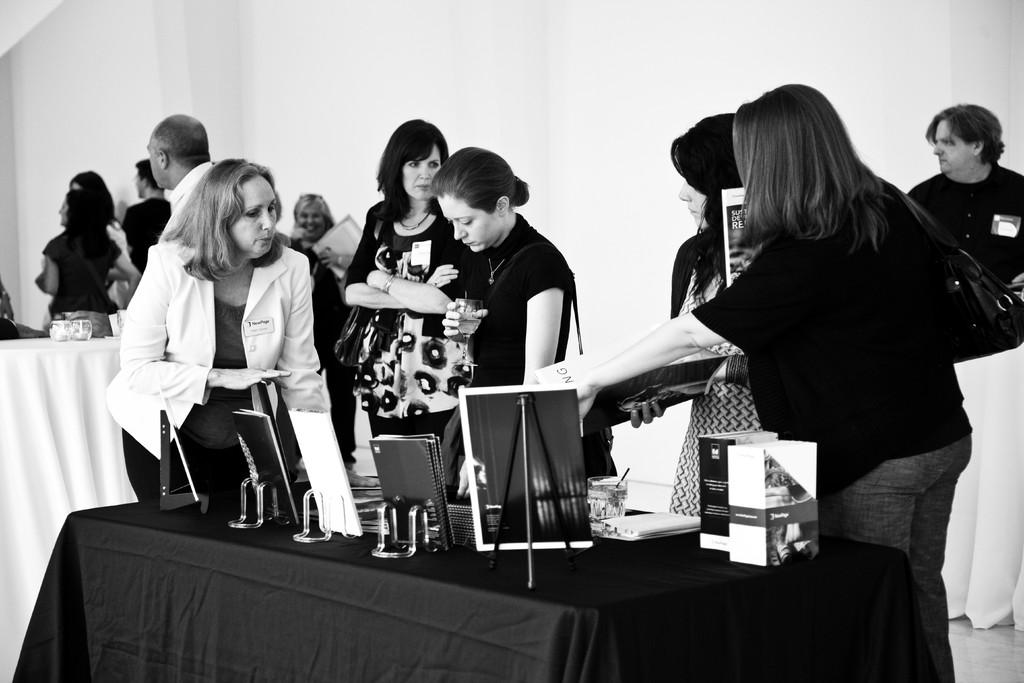What is the main subject of the image? The main subject of the image is a group of women standing in the middle of the image. Can you describe the setting or context of the image? There are no specific details about the setting or context provided, but the presence of the women suggests a social or group activity. What else can be seen in the image besides the group of women? There are books on a table at the bottom of the image. What type of watch is the woman on the left wearing in the image? There is no watch visible on any of the women in the image. Why are the women crying in the image? There is no indication that the women are crying in the image; they are simply standing together. 